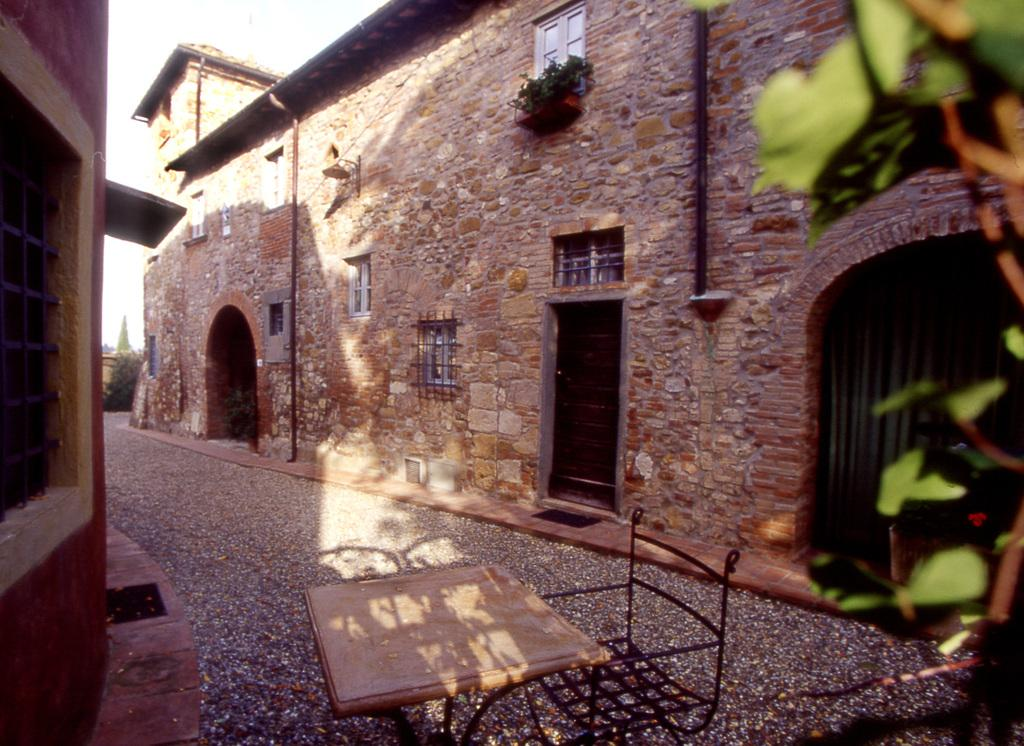What type of furniture is present in the image? There is a table and a chair in the image. What material are the walls made of in the image? The walls in the image are made of stone. Who is telling a joke while sitting on the chair in the image? There is no person present in the image, so no one is telling a joke or sitting on the chair. 